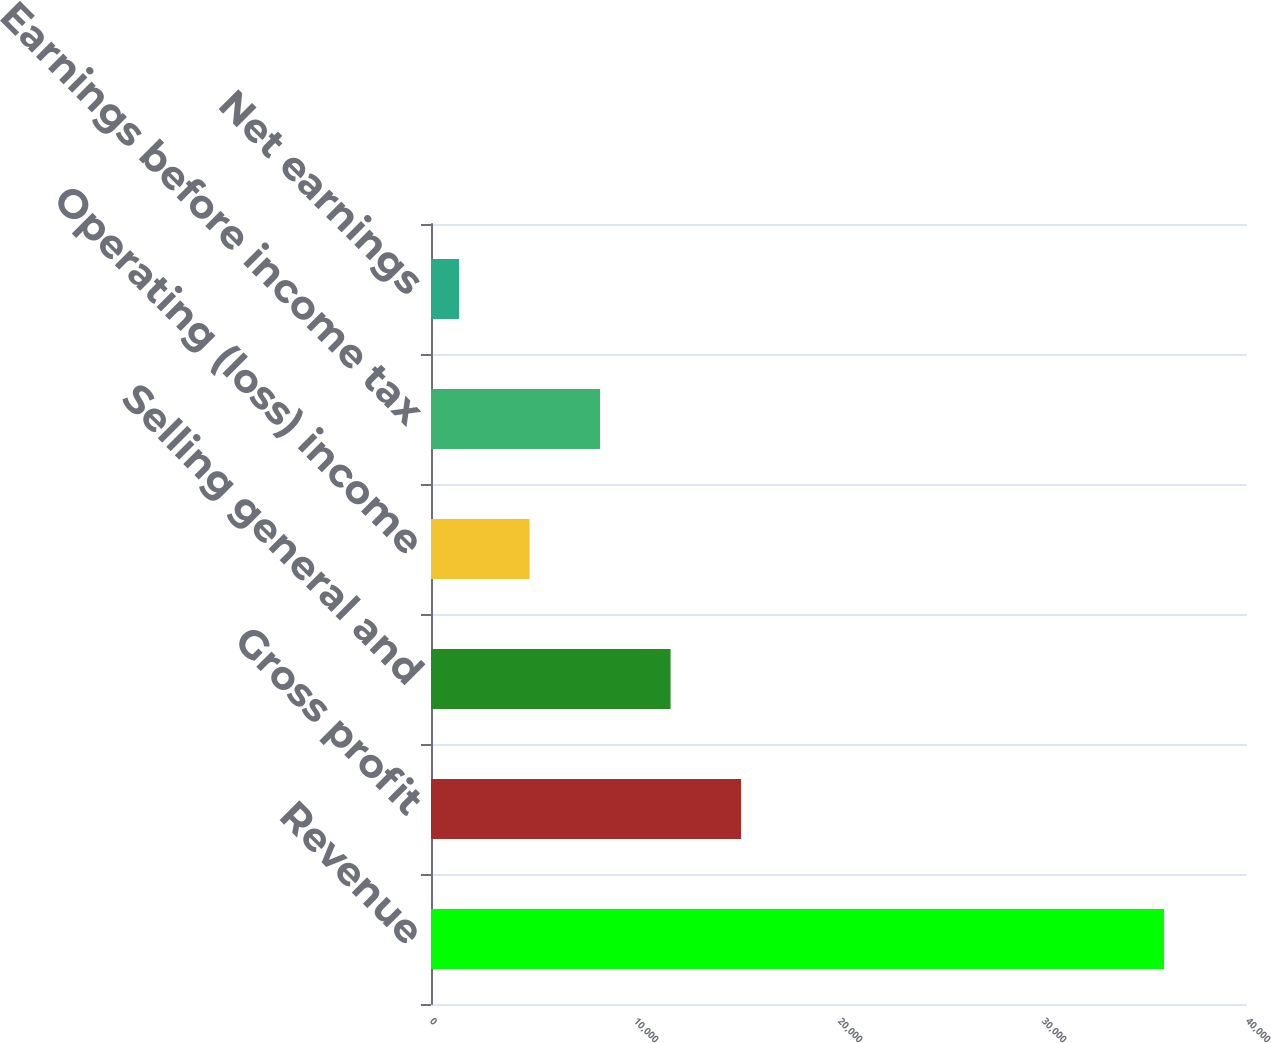Convert chart to OTSL. <chart><loc_0><loc_0><loc_500><loc_500><bar_chart><fcel>Revenue<fcel>Gross profit<fcel>Selling general and<fcel>Operating (loss) income<fcel>Earnings before income tax<fcel>Net earnings<nl><fcel>35934<fcel>15199.8<fcel>11744.1<fcel>4832.7<fcel>8288.4<fcel>1377<nl></chart> 